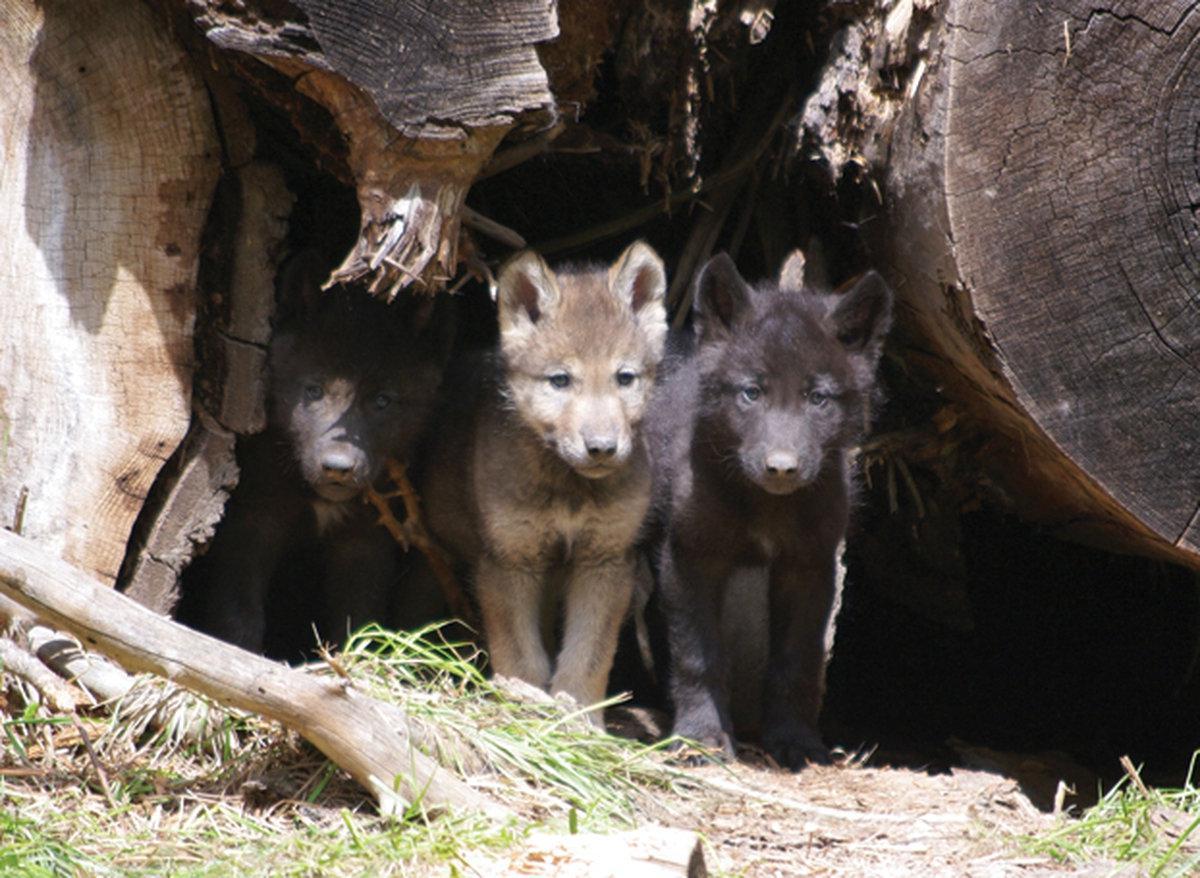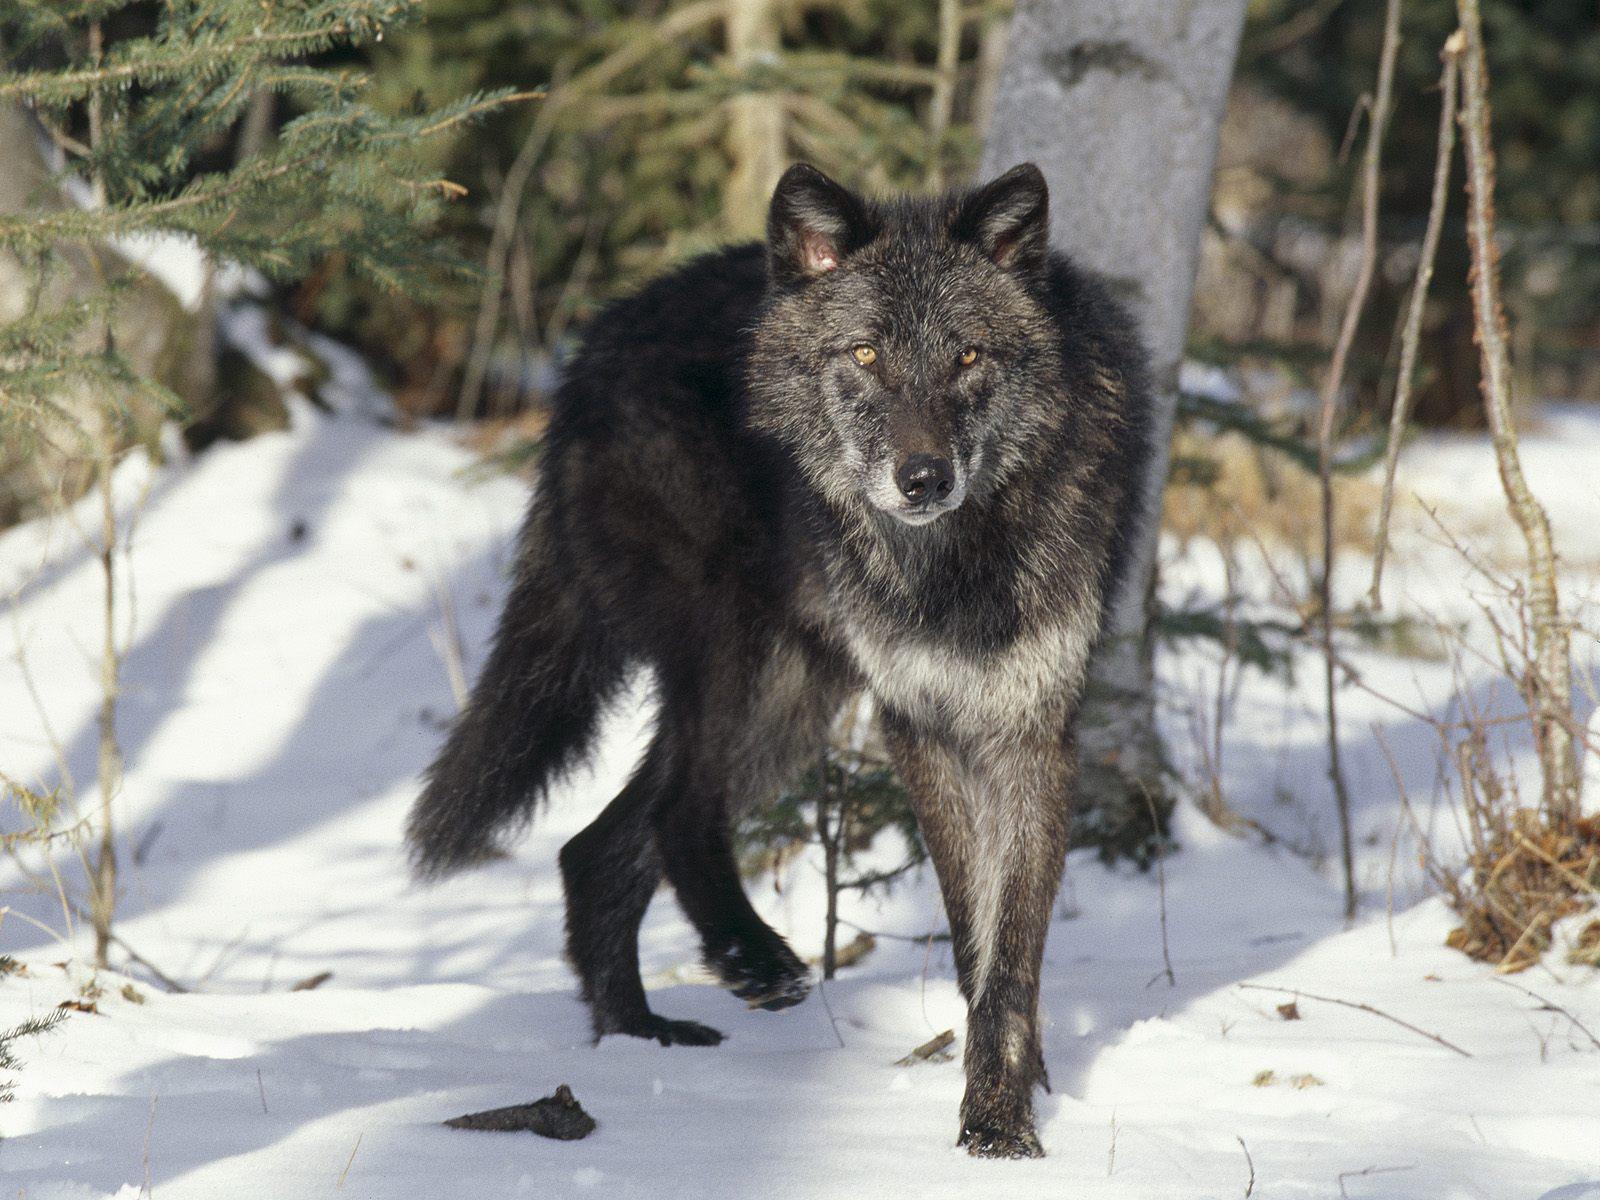The first image is the image on the left, the second image is the image on the right. Given the left and right images, does the statement "At least one wolf has its mouth open." hold true? Answer yes or no. No. 